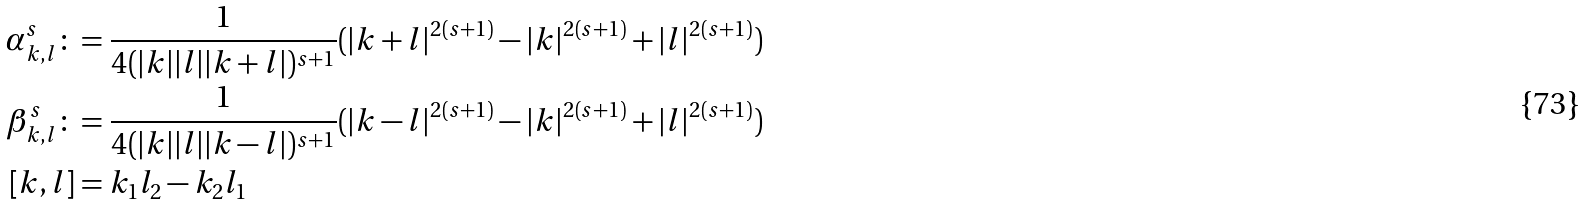<formula> <loc_0><loc_0><loc_500><loc_500>\alpha ^ { s } _ { k , l } \colon & = \frac { 1 } { 4 ( | k | | l | | k + l | ) ^ { s + 1 } } ( | k + l | ^ { 2 ( s + 1 ) } - | k | ^ { 2 ( s + 1 ) } + | l | ^ { 2 ( s + 1 ) } ) \\ \beta ^ { s } _ { k , l } \colon & = \frac { 1 } { 4 ( | k | | l | | k - l | ) ^ { s + 1 } } ( | k - l | ^ { 2 ( s + 1 ) } - | k | ^ { 2 ( s + 1 ) } + | l | ^ { 2 ( s + 1 ) } ) \\ [ k , l ] & = k _ { 1 } l _ { 2 } - k _ { 2 } l _ { 1 }</formula> 